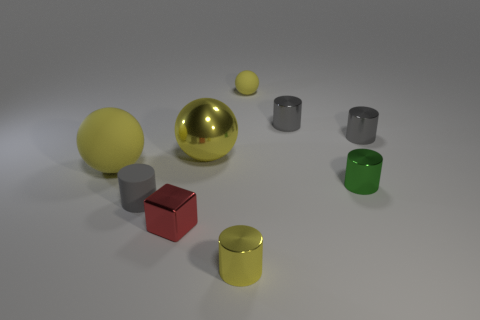How many yellow balls must be subtracted to get 1 yellow balls? 2 Subtract all yellow matte balls. How many balls are left? 1 Subtract all yellow cylinders. How many cylinders are left? 4 Subtract 3 cylinders. How many cylinders are left? 2 Subtract 1 yellow spheres. How many objects are left? 8 Subtract all cubes. How many objects are left? 8 Subtract all green cylinders. Subtract all cyan balls. How many cylinders are left? 4 Subtract all purple cylinders. How many blue balls are left? 0 Subtract all tiny metal spheres. Subtract all red cubes. How many objects are left? 8 Add 5 small spheres. How many small spheres are left? 6 